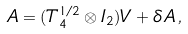<formula> <loc_0><loc_0><loc_500><loc_500>A = ( T _ { 4 } ^ { 1 / 2 } \otimes I _ { 2 } ) V + \delta A \, ,</formula> 